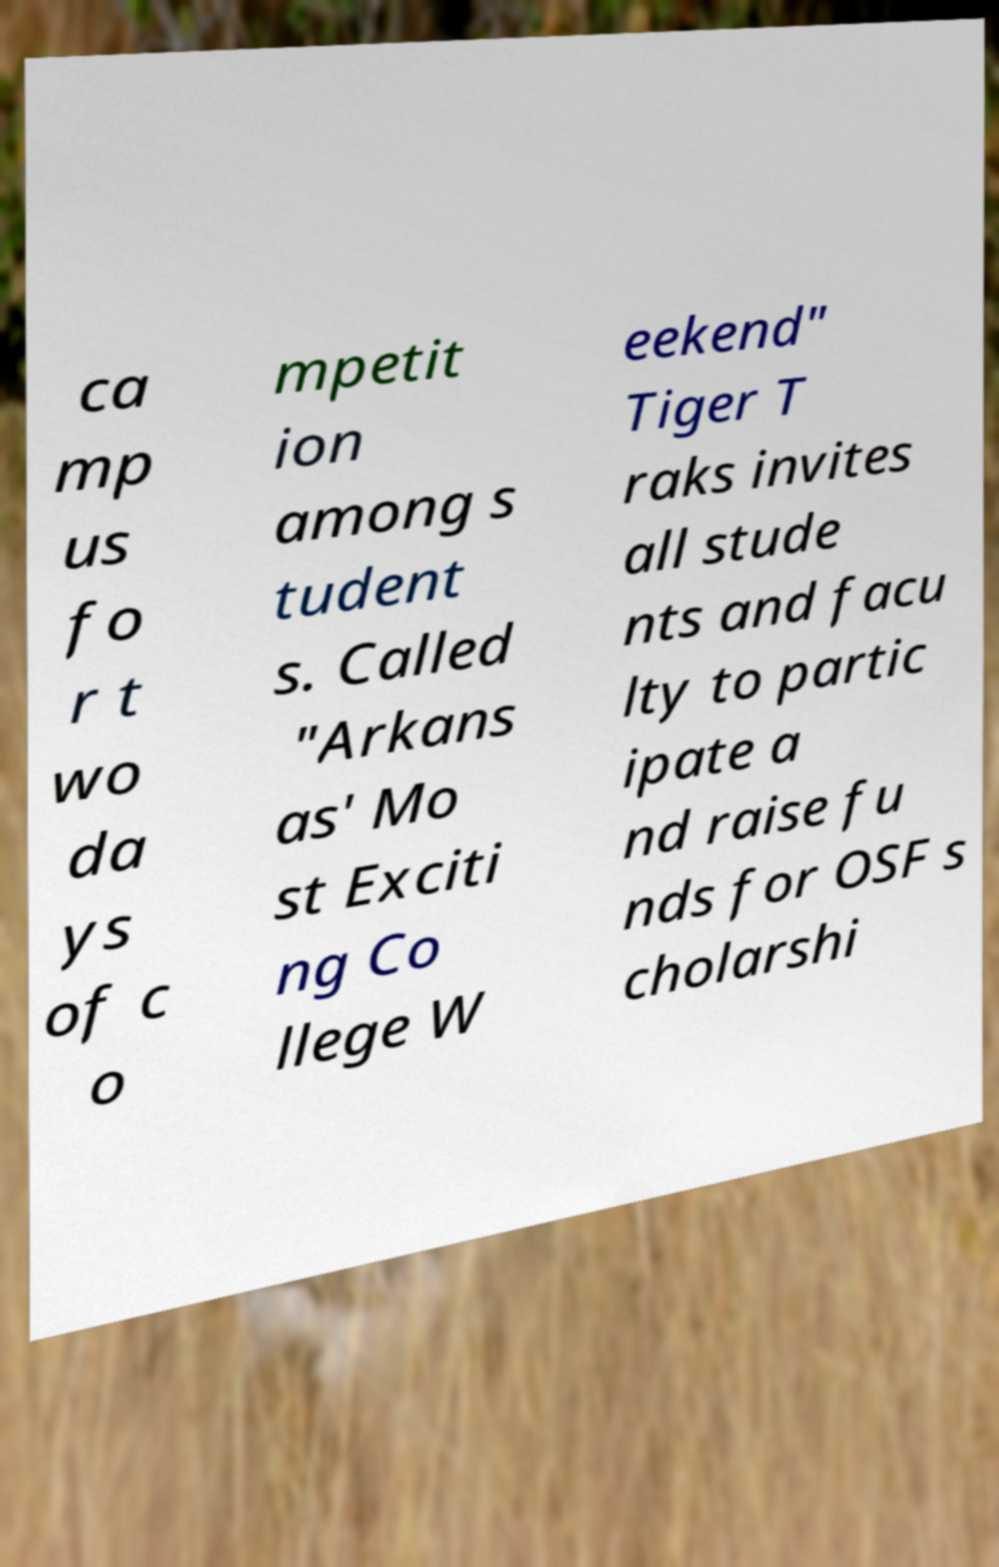Can you read and provide the text displayed in the image?This photo seems to have some interesting text. Can you extract and type it out for me? ca mp us fo r t wo da ys of c o mpetit ion among s tudent s. Called "Arkans as' Mo st Exciti ng Co llege W eekend" Tiger T raks invites all stude nts and facu lty to partic ipate a nd raise fu nds for OSF s cholarshi 